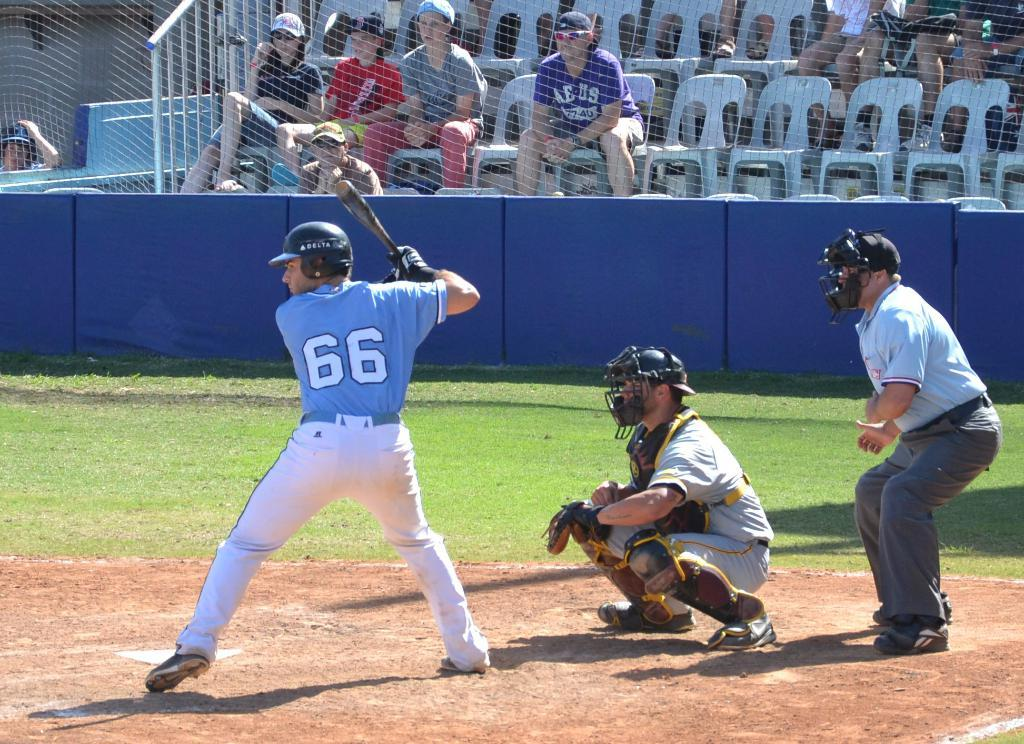<image>
Write a terse but informative summary of the picture. a baseball batter with the numbere 66 on the back of his jersey 